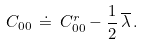<formula> <loc_0><loc_0><loc_500><loc_500>C _ { 0 0 } \, \doteq \, C _ { 0 0 } ^ { r } - \frac { 1 } { 2 } \, \overline { \lambda } \, .</formula> 